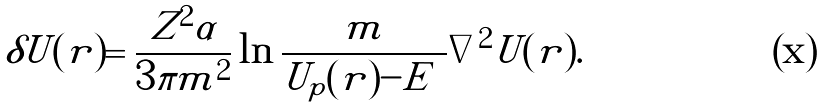Convert formula to latex. <formula><loc_0><loc_0><loc_500><loc_500>\delta U ( { r } ) = \frac { Z ^ { 2 } \alpha } { 3 \pi m ^ { 2 } } \ln \frac { m } { | U _ { p } ( r ) - E | } \nabla ^ { 2 } U ( { r } ) .</formula> 